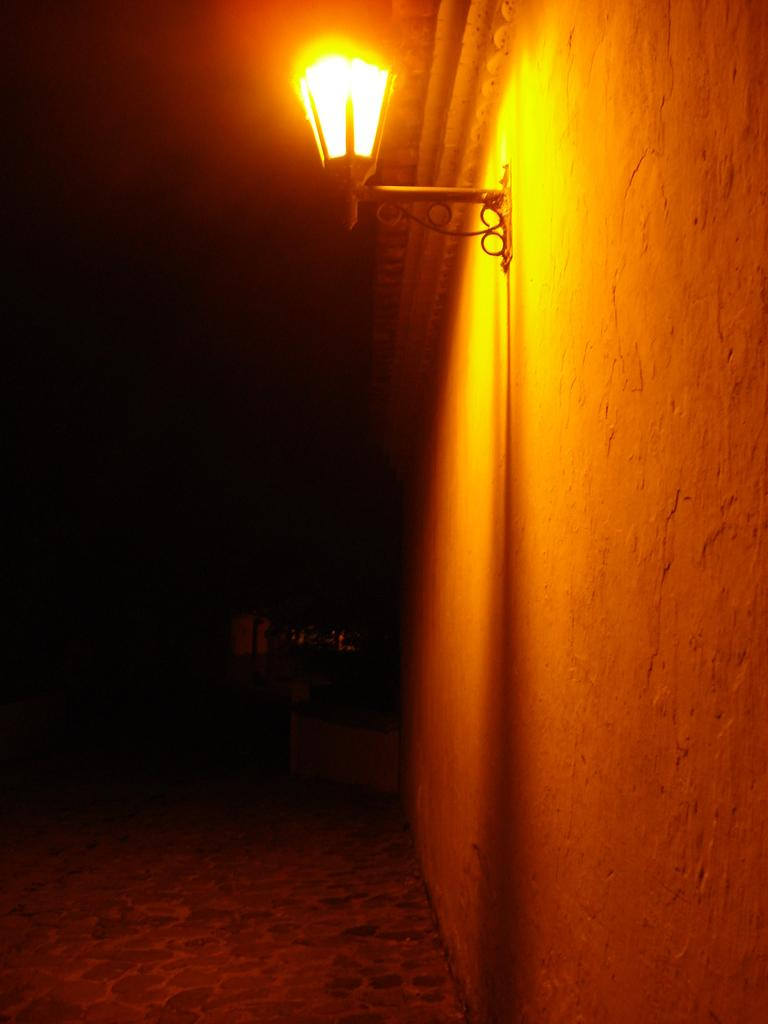What object is located at the top side of the image? There is a lamp in the image, and it is at the top side. Can you describe the background of the image? The background of the image is dark. How many rabbits can be seen hiding in the bushes in the image? There are no bushes or rabbits present in the image; it features a lamp at the top side with a dark background. 